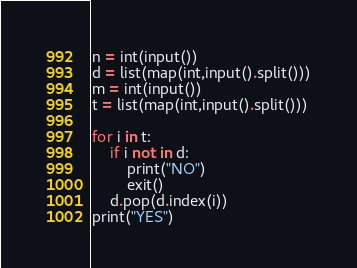Convert code to text. <code><loc_0><loc_0><loc_500><loc_500><_Python_>n = int(input())
d = list(map(int,input().split()))
m = int(input())
t = list(map(int,input().split()))

for i in t:
    if i not in d:
        print("NO")
        exit()
    d.pop(d.index(i))
print("YES")</code> 